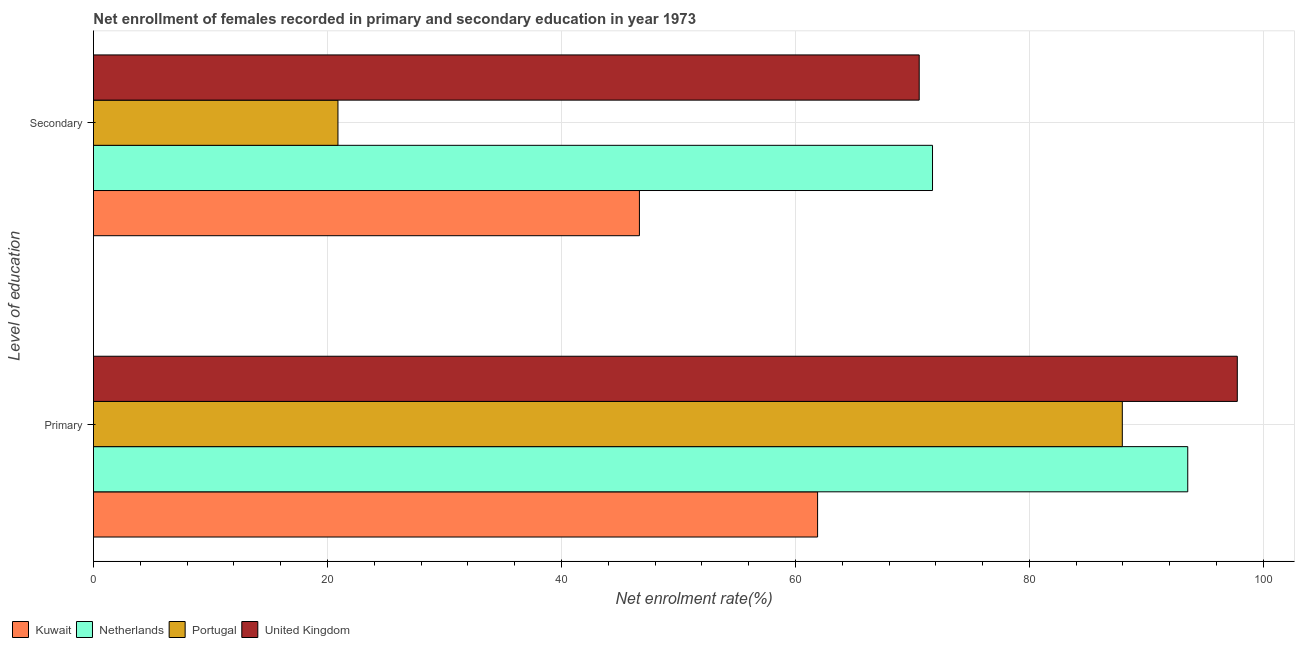How many groups of bars are there?
Your answer should be very brief. 2. Are the number of bars per tick equal to the number of legend labels?
Keep it short and to the point. Yes. How many bars are there on the 2nd tick from the top?
Make the answer very short. 4. How many bars are there on the 2nd tick from the bottom?
Your answer should be very brief. 4. What is the label of the 1st group of bars from the top?
Provide a short and direct response. Secondary. What is the enrollment rate in secondary education in Portugal?
Your answer should be very brief. 20.9. Across all countries, what is the maximum enrollment rate in secondary education?
Make the answer very short. 71.72. Across all countries, what is the minimum enrollment rate in secondary education?
Give a very brief answer. 20.9. In which country was the enrollment rate in secondary education maximum?
Your response must be concise. Netherlands. What is the total enrollment rate in secondary education in the graph?
Ensure brevity in your answer.  209.87. What is the difference between the enrollment rate in secondary education in Portugal and that in Netherlands?
Your answer should be very brief. -50.82. What is the difference between the enrollment rate in primary education in Netherlands and the enrollment rate in secondary education in Portugal?
Keep it short and to the point. 72.64. What is the average enrollment rate in primary education per country?
Give a very brief answer. 85.29. What is the difference between the enrollment rate in primary education and enrollment rate in secondary education in Portugal?
Offer a terse response. 67.05. What is the ratio of the enrollment rate in secondary education in United Kingdom to that in Kuwait?
Your answer should be very brief. 1.51. Is the enrollment rate in primary education in Portugal less than that in Netherlands?
Offer a very short reply. Yes. In how many countries, is the enrollment rate in primary education greater than the average enrollment rate in primary education taken over all countries?
Your answer should be very brief. 3. What does the 3rd bar from the top in Primary represents?
Make the answer very short. Netherlands. How many countries are there in the graph?
Give a very brief answer. 4. Does the graph contain grids?
Ensure brevity in your answer.  Yes. Where does the legend appear in the graph?
Offer a very short reply. Bottom left. What is the title of the graph?
Keep it short and to the point. Net enrollment of females recorded in primary and secondary education in year 1973. Does "Cambodia" appear as one of the legend labels in the graph?
Make the answer very short. No. What is the label or title of the X-axis?
Ensure brevity in your answer.  Net enrolment rate(%). What is the label or title of the Y-axis?
Offer a terse response. Level of education. What is the Net enrolment rate(%) in Kuwait in Primary?
Offer a terse response. 61.9. What is the Net enrolment rate(%) of Netherlands in Primary?
Keep it short and to the point. 93.54. What is the Net enrolment rate(%) in Portugal in Primary?
Your answer should be very brief. 87.94. What is the Net enrolment rate(%) of United Kingdom in Primary?
Keep it short and to the point. 97.77. What is the Net enrolment rate(%) of Kuwait in Secondary?
Keep it short and to the point. 46.67. What is the Net enrolment rate(%) of Netherlands in Secondary?
Make the answer very short. 71.72. What is the Net enrolment rate(%) in Portugal in Secondary?
Keep it short and to the point. 20.9. What is the Net enrolment rate(%) of United Kingdom in Secondary?
Offer a terse response. 70.58. Across all Level of education, what is the maximum Net enrolment rate(%) in Kuwait?
Provide a succinct answer. 61.9. Across all Level of education, what is the maximum Net enrolment rate(%) in Netherlands?
Make the answer very short. 93.54. Across all Level of education, what is the maximum Net enrolment rate(%) in Portugal?
Offer a terse response. 87.94. Across all Level of education, what is the maximum Net enrolment rate(%) of United Kingdom?
Keep it short and to the point. 97.77. Across all Level of education, what is the minimum Net enrolment rate(%) in Kuwait?
Make the answer very short. 46.67. Across all Level of education, what is the minimum Net enrolment rate(%) in Netherlands?
Make the answer very short. 71.72. Across all Level of education, what is the minimum Net enrolment rate(%) of Portugal?
Make the answer very short. 20.9. Across all Level of education, what is the minimum Net enrolment rate(%) in United Kingdom?
Provide a succinct answer. 70.58. What is the total Net enrolment rate(%) of Kuwait in the graph?
Your answer should be very brief. 108.56. What is the total Net enrolment rate(%) of Netherlands in the graph?
Ensure brevity in your answer.  165.26. What is the total Net enrolment rate(%) in Portugal in the graph?
Provide a succinct answer. 108.84. What is the total Net enrolment rate(%) of United Kingdom in the graph?
Make the answer very short. 168.35. What is the difference between the Net enrolment rate(%) in Kuwait in Primary and that in Secondary?
Ensure brevity in your answer.  15.23. What is the difference between the Net enrolment rate(%) of Netherlands in Primary and that in Secondary?
Provide a succinct answer. 21.82. What is the difference between the Net enrolment rate(%) in Portugal in Primary and that in Secondary?
Make the answer very short. 67.05. What is the difference between the Net enrolment rate(%) of United Kingdom in Primary and that in Secondary?
Your answer should be very brief. 27.19. What is the difference between the Net enrolment rate(%) of Kuwait in Primary and the Net enrolment rate(%) of Netherlands in Secondary?
Your answer should be very brief. -9.82. What is the difference between the Net enrolment rate(%) of Kuwait in Primary and the Net enrolment rate(%) of Portugal in Secondary?
Your answer should be very brief. 41. What is the difference between the Net enrolment rate(%) of Kuwait in Primary and the Net enrolment rate(%) of United Kingdom in Secondary?
Offer a very short reply. -8.69. What is the difference between the Net enrolment rate(%) in Netherlands in Primary and the Net enrolment rate(%) in Portugal in Secondary?
Offer a very short reply. 72.64. What is the difference between the Net enrolment rate(%) in Netherlands in Primary and the Net enrolment rate(%) in United Kingdom in Secondary?
Your answer should be compact. 22.95. What is the difference between the Net enrolment rate(%) in Portugal in Primary and the Net enrolment rate(%) in United Kingdom in Secondary?
Ensure brevity in your answer.  17.36. What is the average Net enrolment rate(%) in Kuwait per Level of education?
Provide a short and direct response. 54.28. What is the average Net enrolment rate(%) in Netherlands per Level of education?
Give a very brief answer. 82.63. What is the average Net enrolment rate(%) of Portugal per Level of education?
Your response must be concise. 54.42. What is the average Net enrolment rate(%) of United Kingdom per Level of education?
Provide a short and direct response. 84.18. What is the difference between the Net enrolment rate(%) of Kuwait and Net enrolment rate(%) of Netherlands in Primary?
Ensure brevity in your answer.  -31.64. What is the difference between the Net enrolment rate(%) of Kuwait and Net enrolment rate(%) of Portugal in Primary?
Keep it short and to the point. -26.05. What is the difference between the Net enrolment rate(%) of Kuwait and Net enrolment rate(%) of United Kingdom in Primary?
Your answer should be very brief. -35.88. What is the difference between the Net enrolment rate(%) in Netherlands and Net enrolment rate(%) in Portugal in Primary?
Provide a succinct answer. 5.59. What is the difference between the Net enrolment rate(%) in Netherlands and Net enrolment rate(%) in United Kingdom in Primary?
Provide a short and direct response. -4.24. What is the difference between the Net enrolment rate(%) of Portugal and Net enrolment rate(%) of United Kingdom in Primary?
Make the answer very short. -9.83. What is the difference between the Net enrolment rate(%) in Kuwait and Net enrolment rate(%) in Netherlands in Secondary?
Your answer should be compact. -25.05. What is the difference between the Net enrolment rate(%) of Kuwait and Net enrolment rate(%) of Portugal in Secondary?
Ensure brevity in your answer.  25.77. What is the difference between the Net enrolment rate(%) in Kuwait and Net enrolment rate(%) in United Kingdom in Secondary?
Provide a succinct answer. -23.92. What is the difference between the Net enrolment rate(%) of Netherlands and Net enrolment rate(%) of Portugal in Secondary?
Offer a terse response. 50.82. What is the difference between the Net enrolment rate(%) in Netherlands and Net enrolment rate(%) in United Kingdom in Secondary?
Your answer should be compact. 1.14. What is the difference between the Net enrolment rate(%) in Portugal and Net enrolment rate(%) in United Kingdom in Secondary?
Provide a succinct answer. -49.68. What is the ratio of the Net enrolment rate(%) in Kuwait in Primary to that in Secondary?
Offer a terse response. 1.33. What is the ratio of the Net enrolment rate(%) of Netherlands in Primary to that in Secondary?
Ensure brevity in your answer.  1.3. What is the ratio of the Net enrolment rate(%) in Portugal in Primary to that in Secondary?
Your answer should be compact. 4.21. What is the ratio of the Net enrolment rate(%) in United Kingdom in Primary to that in Secondary?
Give a very brief answer. 1.39. What is the difference between the highest and the second highest Net enrolment rate(%) in Kuwait?
Ensure brevity in your answer.  15.23. What is the difference between the highest and the second highest Net enrolment rate(%) of Netherlands?
Ensure brevity in your answer.  21.82. What is the difference between the highest and the second highest Net enrolment rate(%) in Portugal?
Provide a short and direct response. 67.05. What is the difference between the highest and the second highest Net enrolment rate(%) of United Kingdom?
Your response must be concise. 27.19. What is the difference between the highest and the lowest Net enrolment rate(%) of Kuwait?
Provide a succinct answer. 15.23. What is the difference between the highest and the lowest Net enrolment rate(%) of Netherlands?
Offer a very short reply. 21.82. What is the difference between the highest and the lowest Net enrolment rate(%) of Portugal?
Your answer should be very brief. 67.05. What is the difference between the highest and the lowest Net enrolment rate(%) in United Kingdom?
Provide a short and direct response. 27.19. 